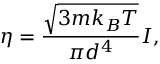<formula> <loc_0><loc_0><loc_500><loc_500>\eta = \frac { \sqrt { 3 m k _ { B } T } } { \pi d ^ { 4 } } I ,</formula> 